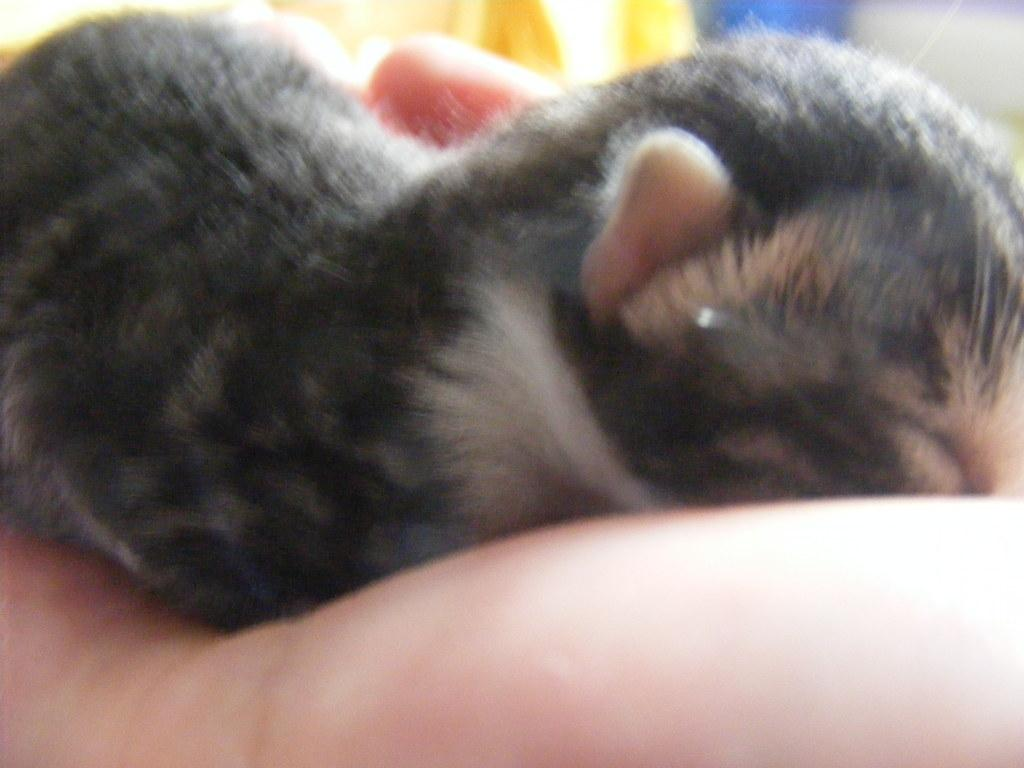What is the main subject of the image? There is a person in the image. What part of the person's body is visible? The person's hand is visible. What is on the person's hand? There is an animal on the person's hand. What color is the observation tower in the image? There is no observation tower present in the image. 